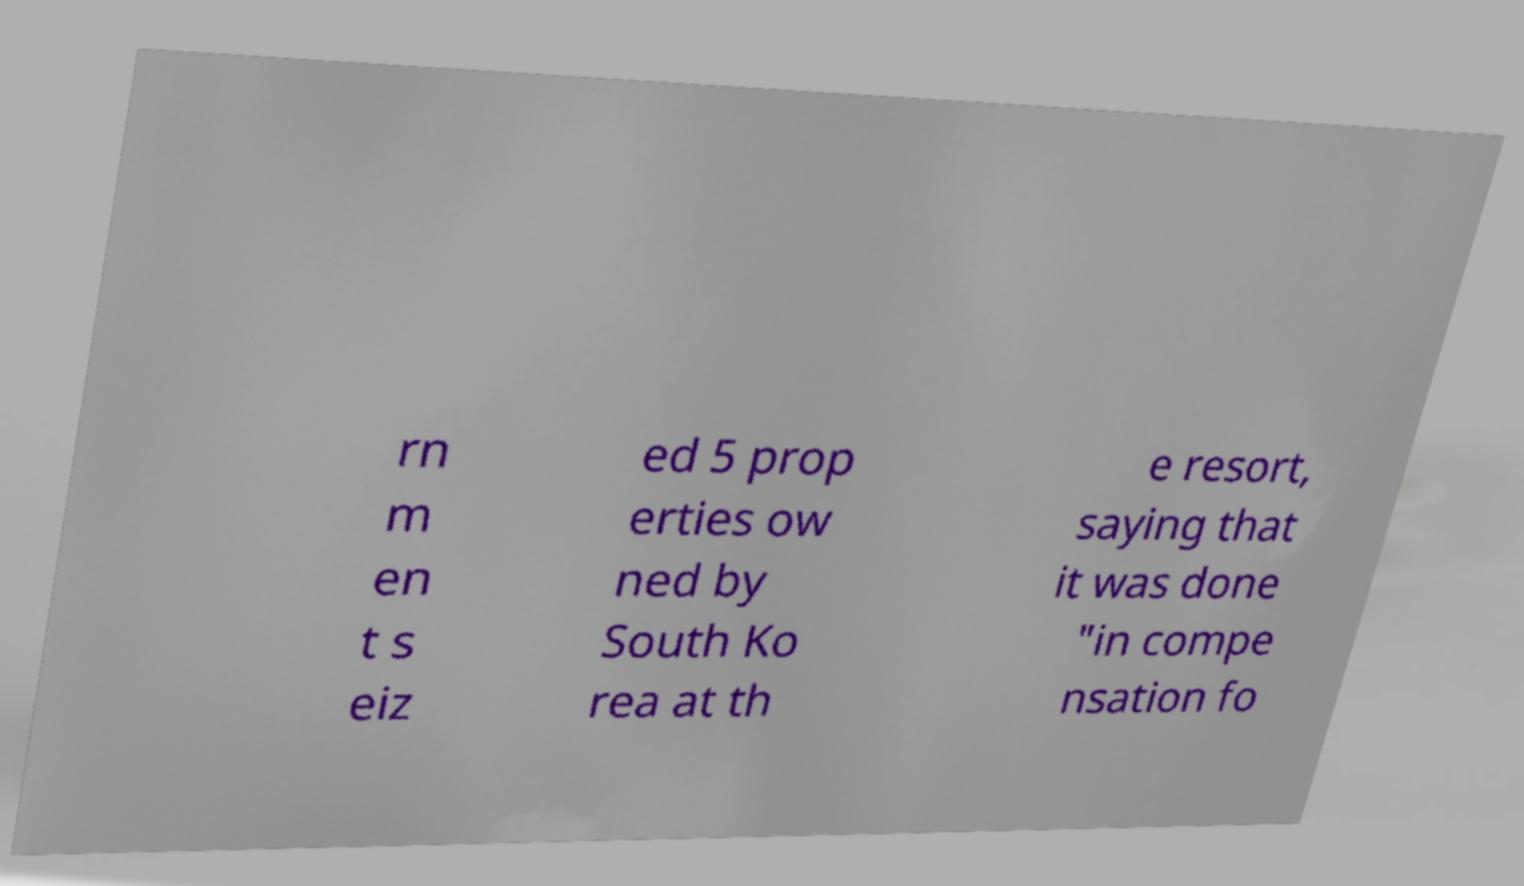Can you accurately transcribe the text from the provided image for me? rn m en t s eiz ed 5 prop erties ow ned by South Ko rea at th e resort, saying that it was done "in compe nsation fo 